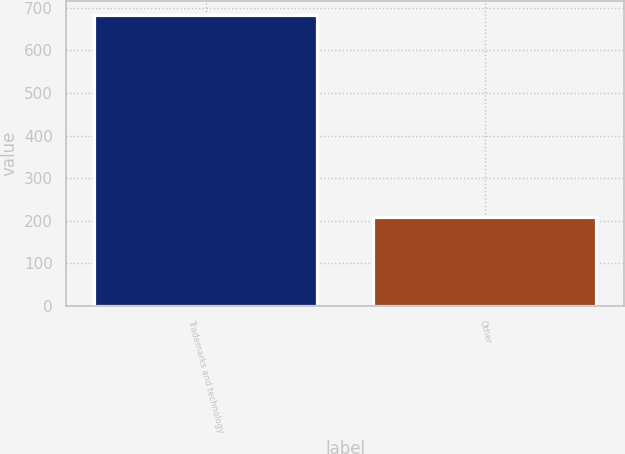<chart> <loc_0><loc_0><loc_500><loc_500><bar_chart><fcel>Trademarks and technology<fcel>Other<nl><fcel>682<fcel>209<nl></chart> 